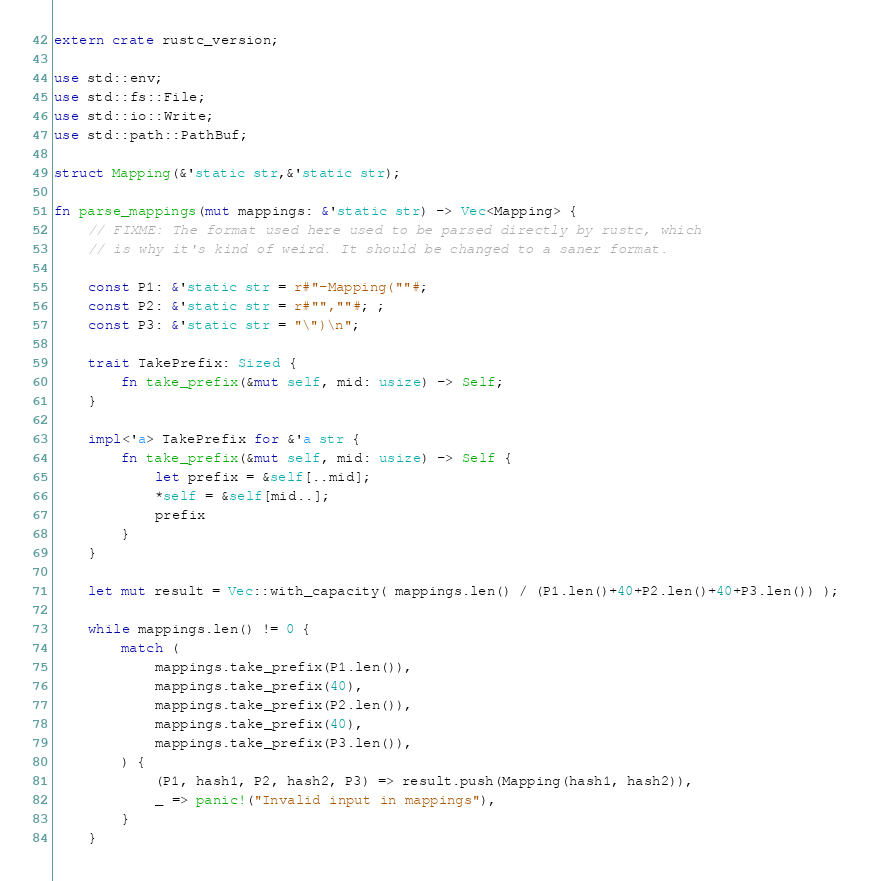Convert code to text. <code><loc_0><loc_0><loc_500><loc_500><_Rust_>extern crate rustc_version;

use std::env;
use std::fs::File;
use std::io::Write;
use std::path::PathBuf;

struct Mapping(&'static str,&'static str);

fn parse_mappings(mut mappings: &'static str) -> Vec<Mapping> {
	// FIXME: The format used here used to be parsed directly by rustc, which
	// is why it's kind of weird. It should be changed to a saner format.

	const P1: &'static str = r#"-Mapping(""#;
	const P2: &'static str = r#"",""#; ;
	const P3: &'static str = "\")\n";

	trait TakePrefix: Sized {
		fn take_prefix(&mut self, mid: usize) -> Self;
	}

	impl<'a> TakePrefix for &'a str {
		fn take_prefix(&mut self, mid: usize) -> Self {
			let prefix = &self[..mid];
			*self = &self[mid..];
			prefix
		}
	}

	let mut result = Vec::with_capacity( mappings.len() / (P1.len()+40+P2.len()+40+P3.len()) );

	while mappings.len() != 0 {
		match (
			mappings.take_prefix(P1.len()),
			mappings.take_prefix(40),
			mappings.take_prefix(P2.len()),
			mappings.take_prefix(40),
			mappings.take_prefix(P3.len()),
		) {
			(P1, hash1, P2, hash2, P3) => result.push(Mapping(hash1, hash2)),
			_ => panic!("Invalid input in mappings"),
		}
	}
</code> 